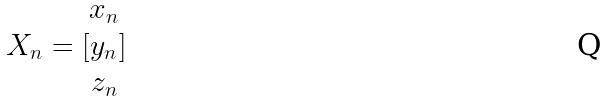Convert formula to latex. <formula><loc_0><loc_0><loc_500><loc_500>X _ { n } = [ \begin{matrix} x _ { n } \\ y _ { n } \\ z _ { n } \end{matrix} ]</formula> 